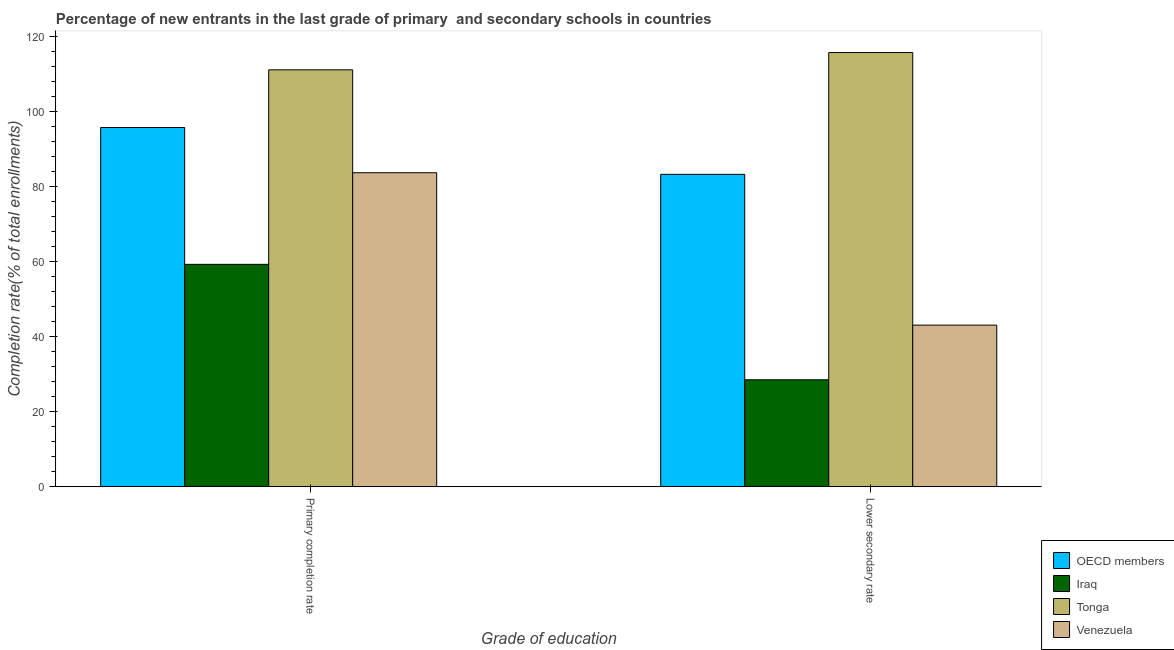Are the number of bars per tick equal to the number of legend labels?
Provide a short and direct response. Yes. Are the number of bars on each tick of the X-axis equal?
Make the answer very short. Yes. How many bars are there on the 2nd tick from the left?
Make the answer very short. 4. How many bars are there on the 2nd tick from the right?
Keep it short and to the point. 4. What is the label of the 2nd group of bars from the left?
Ensure brevity in your answer.  Lower secondary rate. What is the completion rate in secondary schools in OECD members?
Provide a short and direct response. 83.3. Across all countries, what is the maximum completion rate in secondary schools?
Your response must be concise. 115.78. Across all countries, what is the minimum completion rate in primary schools?
Offer a terse response. 59.29. In which country was the completion rate in secondary schools maximum?
Give a very brief answer. Tonga. In which country was the completion rate in primary schools minimum?
Your answer should be compact. Iraq. What is the total completion rate in secondary schools in the graph?
Ensure brevity in your answer.  270.68. What is the difference between the completion rate in secondary schools in Tonga and that in OECD members?
Your answer should be compact. 32.48. What is the difference between the completion rate in secondary schools in Tonga and the completion rate in primary schools in OECD members?
Provide a succinct answer. 20. What is the average completion rate in secondary schools per country?
Ensure brevity in your answer.  67.67. What is the difference between the completion rate in primary schools and completion rate in secondary schools in Venezuela?
Give a very brief answer. 40.64. What is the ratio of the completion rate in secondary schools in Tonga to that in OECD members?
Make the answer very short. 1.39. In how many countries, is the completion rate in secondary schools greater than the average completion rate in secondary schools taken over all countries?
Give a very brief answer. 2. What does the 3rd bar from the left in Primary completion rate represents?
Ensure brevity in your answer.  Tonga. What does the 3rd bar from the right in Lower secondary rate represents?
Your response must be concise. Iraq. Are all the bars in the graph horizontal?
Ensure brevity in your answer.  No. What is the difference between two consecutive major ticks on the Y-axis?
Your answer should be compact. 20. Does the graph contain any zero values?
Provide a short and direct response. No. Does the graph contain grids?
Keep it short and to the point. No. What is the title of the graph?
Offer a terse response. Percentage of new entrants in the last grade of primary  and secondary schools in countries. Does "Bosnia and Herzegovina" appear as one of the legend labels in the graph?
Ensure brevity in your answer.  No. What is the label or title of the X-axis?
Offer a terse response. Grade of education. What is the label or title of the Y-axis?
Provide a short and direct response. Completion rate(% of total enrollments). What is the Completion rate(% of total enrollments) of OECD members in Primary completion rate?
Give a very brief answer. 95.78. What is the Completion rate(% of total enrollments) in Iraq in Primary completion rate?
Give a very brief answer. 59.29. What is the Completion rate(% of total enrollments) in Tonga in Primary completion rate?
Your answer should be compact. 111.16. What is the Completion rate(% of total enrollments) in Venezuela in Primary completion rate?
Ensure brevity in your answer.  83.72. What is the Completion rate(% of total enrollments) of OECD members in Lower secondary rate?
Offer a terse response. 83.3. What is the Completion rate(% of total enrollments) of Iraq in Lower secondary rate?
Keep it short and to the point. 28.52. What is the Completion rate(% of total enrollments) of Tonga in Lower secondary rate?
Keep it short and to the point. 115.78. What is the Completion rate(% of total enrollments) of Venezuela in Lower secondary rate?
Provide a short and direct response. 43.09. Across all Grade of education, what is the maximum Completion rate(% of total enrollments) of OECD members?
Your answer should be very brief. 95.78. Across all Grade of education, what is the maximum Completion rate(% of total enrollments) of Iraq?
Give a very brief answer. 59.29. Across all Grade of education, what is the maximum Completion rate(% of total enrollments) of Tonga?
Offer a very short reply. 115.78. Across all Grade of education, what is the maximum Completion rate(% of total enrollments) of Venezuela?
Offer a terse response. 83.72. Across all Grade of education, what is the minimum Completion rate(% of total enrollments) of OECD members?
Your answer should be very brief. 83.3. Across all Grade of education, what is the minimum Completion rate(% of total enrollments) in Iraq?
Provide a short and direct response. 28.52. Across all Grade of education, what is the minimum Completion rate(% of total enrollments) of Tonga?
Offer a terse response. 111.16. Across all Grade of education, what is the minimum Completion rate(% of total enrollments) in Venezuela?
Provide a succinct answer. 43.09. What is the total Completion rate(% of total enrollments) in OECD members in the graph?
Your answer should be compact. 179.08. What is the total Completion rate(% of total enrollments) in Iraq in the graph?
Offer a very short reply. 87.81. What is the total Completion rate(% of total enrollments) of Tonga in the graph?
Your answer should be very brief. 226.94. What is the total Completion rate(% of total enrollments) in Venezuela in the graph?
Offer a terse response. 126.81. What is the difference between the Completion rate(% of total enrollments) in OECD members in Primary completion rate and that in Lower secondary rate?
Provide a short and direct response. 12.48. What is the difference between the Completion rate(% of total enrollments) of Iraq in Primary completion rate and that in Lower secondary rate?
Give a very brief answer. 30.78. What is the difference between the Completion rate(% of total enrollments) of Tonga in Primary completion rate and that in Lower secondary rate?
Make the answer very short. -4.61. What is the difference between the Completion rate(% of total enrollments) in Venezuela in Primary completion rate and that in Lower secondary rate?
Provide a succinct answer. 40.64. What is the difference between the Completion rate(% of total enrollments) of OECD members in Primary completion rate and the Completion rate(% of total enrollments) of Iraq in Lower secondary rate?
Ensure brevity in your answer.  67.26. What is the difference between the Completion rate(% of total enrollments) in OECD members in Primary completion rate and the Completion rate(% of total enrollments) in Tonga in Lower secondary rate?
Offer a very short reply. -20. What is the difference between the Completion rate(% of total enrollments) of OECD members in Primary completion rate and the Completion rate(% of total enrollments) of Venezuela in Lower secondary rate?
Provide a short and direct response. 52.69. What is the difference between the Completion rate(% of total enrollments) in Iraq in Primary completion rate and the Completion rate(% of total enrollments) in Tonga in Lower secondary rate?
Provide a succinct answer. -56.48. What is the difference between the Completion rate(% of total enrollments) of Iraq in Primary completion rate and the Completion rate(% of total enrollments) of Venezuela in Lower secondary rate?
Make the answer very short. 16.2. What is the difference between the Completion rate(% of total enrollments) of Tonga in Primary completion rate and the Completion rate(% of total enrollments) of Venezuela in Lower secondary rate?
Your answer should be very brief. 68.07. What is the average Completion rate(% of total enrollments) of OECD members per Grade of education?
Ensure brevity in your answer.  89.54. What is the average Completion rate(% of total enrollments) in Iraq per Grade of education?
Provide a succinct answer. 43.91. What is the average Completion rate(% of total enrollments) in Tonga per Grade of education?
Your response must be concise. 113.47. What is the average Completion rate(% of total enrollments) in Venezuela per Grade of education?
Make the answer very short. 63.41. What is the difference between the Completion rate(% of total enrollments) of OECD members and Completion rate(% of total enrollments) of Iraq in Primary completion rate?
Make the answer very short. 36.49. What is the difference between the Completion rate(% of total enrollments) of OECD members and Completion rate(% of total enrollments) of Tonga in Primary completion rate?
Provide a succinct answer. -15.38. What is the difference between the Completion rate(% of total enrollments) of OECD members and Completion rate(% of total enrollments) of Venezuela in Primary completion rate?
Your response must be concise. 12.06. What is the difference between the Completion rate(% of total enrollments) of Iraq and Completion rate(% of total enrollments) of Tonga in Primary completion rate?
Give a very brief answer. -51.87. What is the difference between the Completion rate(% of total enrollments) of Iraq and Completion rate(% of total enrollments) of Venezuela in Primary completion rate?
Your answer should be very brief. -24.43. What is the difference between the Completion rate(% of total enrollments) in Tonga and Completion rate(% of total enrollments) in Venezuela in Primary completion rate?
Keep it short and to the point. 27.44. What is the difference between the Completion rate(% of total enrollments) of OECD members and Completion rate(% of total enrollments) of Iraq in Lower secondary rate?
Offer a terse response. 54.78. What is the difference between the Completion rate(% of total enrollments) of OECD members and Completion rate(% of total enrollments) of Tonga in Lower secondary rate?
Your answer should be compact. -32.48. What is the difference between the Completion rate(% of total enrollments) of OECD members and Completion rate(% of total enrollments) of Venezuela in Lower secondary rate?
Give a very brief answer. 40.21. What is the difference between the Completion rate(% of total enrollments) in Iraq and Completion rate(% of total enrollments) in Tonga in Lower secondary rate?
Offer a terse response. -87.26. What is the difference between the Completion rate(% of total enrollments) of Iraq and Completion rate(% of total enrollments) of Venezuela in Lower secondary rate?
Keep it short and to the point. -14.57. What is the difference between the Completion rate(% of total enrollments) in Tonga and Completion rate(% of total enrollments) in Venezuela in Lower secondary rate?
Keep it short and to the point. 72.69. What is the ratio of the Completion rate(% of total enrollments) in OECD members in Primary completion rate to that in Lower secondary rate?
Provide a succinct answer. 1.15. What is the ratio of the Completion rate(% of total enrollments) in Iraq in Primary completion rate to that in Lower secondary rate?
Provide a succinct answer. 2.08. What is the ratio of the Completion rate(% of total enrollments) of Tonga in Primary completion rate to that in Lower secondary rate?
Ensure brevity in your answer.  0.96. What is the ratio of the Completion rate(% of total enrollments) of Venezuela in Primary completion rate to that in Lower secondary rate?
Your response must be concise. 1.94. What is the difference between the highest and the second highest Completion rate(% of total enrollments) of OECD members?
Provide a succinct answer. 12.48. What is the difference between the highest and the second highest Completion rate(% of total enrollments) in Iraq?
Ensure brevity in your answer.  30.78. What is the difference between the highest and the second highest Completion rate(% of total enrollments) of Tonga?
Make the answer very short. 4.61. What is the difference between the highest and the second highest Completion rate(% of total enrollments) in Venezuela?
Provide a short and direct response. 40.64. What is the difference between the highest and the lowest Completion rate(% of total enrollments) in OECD members?
Ensure brevity in your answer.  12.48. What is the difference between the highest and the lowest Completion rate(% of total enrollments) in Iraq?
Offer a terse response. 30.78. What is the difference between the highest and the lowest Completion rate(% of total enrollments) of Tonga?
Your response must be concise. 4.61. What is the difference between the highest and the lowest Completion rate(% of total enrollments) of Venezuela?
Make the answer very short. 40.64. 